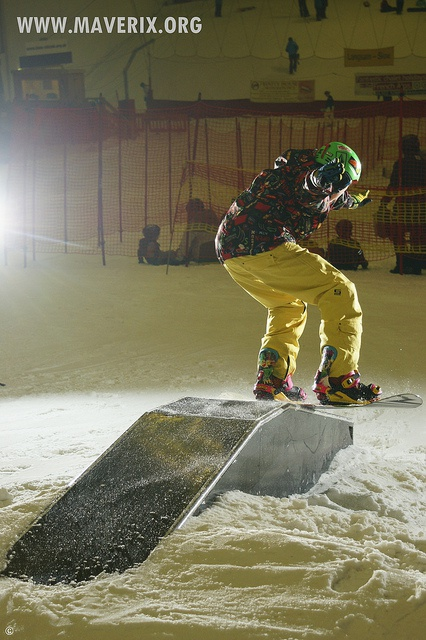Describe the objects in this image and their specific colors. I can see people in black, olive, and maroon tones, people in black and darkgreen tones, people in black and gray tones, people in black, olive, and gray tones, and snowboard in black, darkgray, gray, and lightgray tones in this image. 